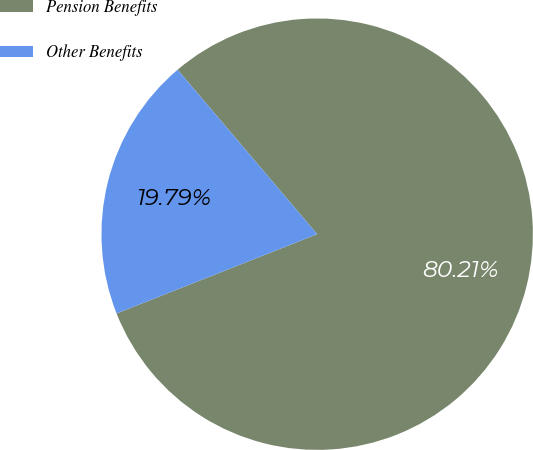<chart> <loc_0><loc_0><loc_500><loc_500><pie_chart><fcel>Pension Benefits<fcel>Other Benefits<nl><fcel>80.21%<fcel>19.79%<nl></chart> 